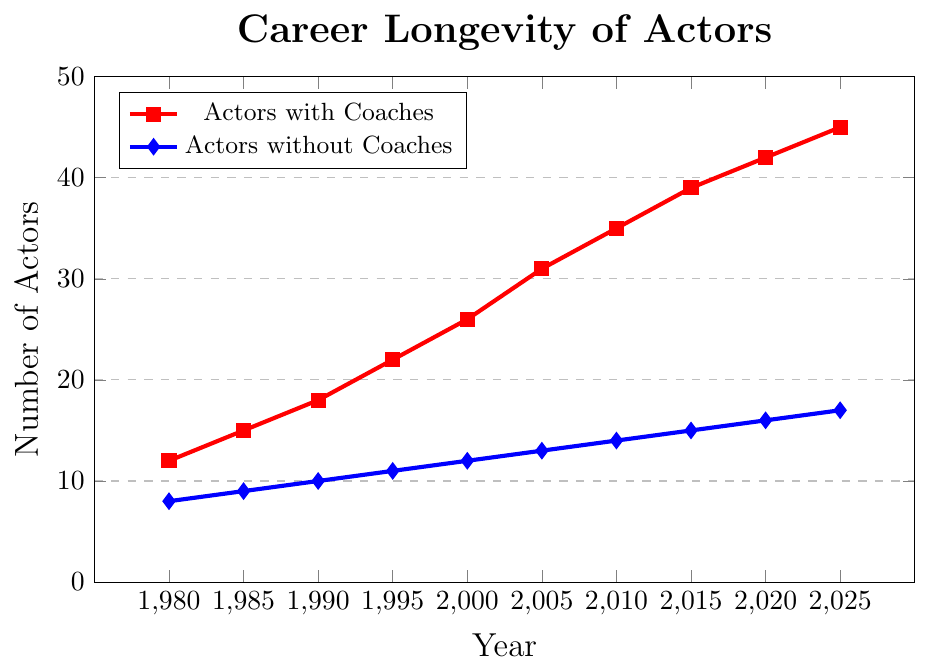How many actors with coaches were there in 2020? Look at the red line marked with squares for the year 2020. The value is 42.
Answer: 42 What's the difference in the number of actors with and without coaches in 2005? The red line (with coaches) shows 31 for 2005, and the blue line (without coaches) shows 13 for the same year. The difference is 31 - 13 = 18.
Answer: 18 Which year shows the highest number of actors without coaches based on the plot? The blue line peaks at its highest point in 2025 where the value is 17.
Answer: 2025 In 1995, how many more actors with coaches are there compared to those without? In 1995, the red line is at 22 and the blue line is at 11. The difference is 22 - 11 = 11.
Answer: 11 Is the trend for actors with coaches increasing or decreasing over the years? Observing the red line, it consistently goes up from 1980 to 2025.
Answer: Increasing What's the percentage increase of actors with coaches from 1980 to 2025? First, find the values in 1980 and 2025 for the red line: 12 and 45 respectively. The increase is 45 - 12 = 33. The percentage increase is (33 / 12) * 100% ≈ 275%.
Answer: 275% Between 1990 and 2000, which group of actors shows a greater increase in numbers? For actors with coaches (red line), the increase is from 18 to 26 which is 8. For actors without coaches (blue line), the increase is from 10 to 12 which is 2.
Answer: Actors with coaches Identify the decade with the highest growth rate for actors with coaches. Calculate the growth for each decade: 1980-1990: 18 - 12 = 6; 1990-2000: 26 - 18 = 8; 2000-2010: 35 - 26 = 9; 2010-2020: 42 - 35 = 7. The decade 2000-2010 has the highest growth of 9.
Answer: 2000-2010 In which year do the number of actors without coaches first reach 15? Following the blue line, it first reaches the value 15 in 2015.
Answer: 2015 Compare the trends of both groups over the entire time period. What can you conclude? Both lines are upward sloping, indicating an increase in the number of actors in each group over time. However, the red line (with coaches) rises at a steeper rate than the blue line (without coaches), suggesting that the number of actors working with coaches is growing faster than those without coaches.
Answer: Actors with coaches are increasing faster than actors without coaches 